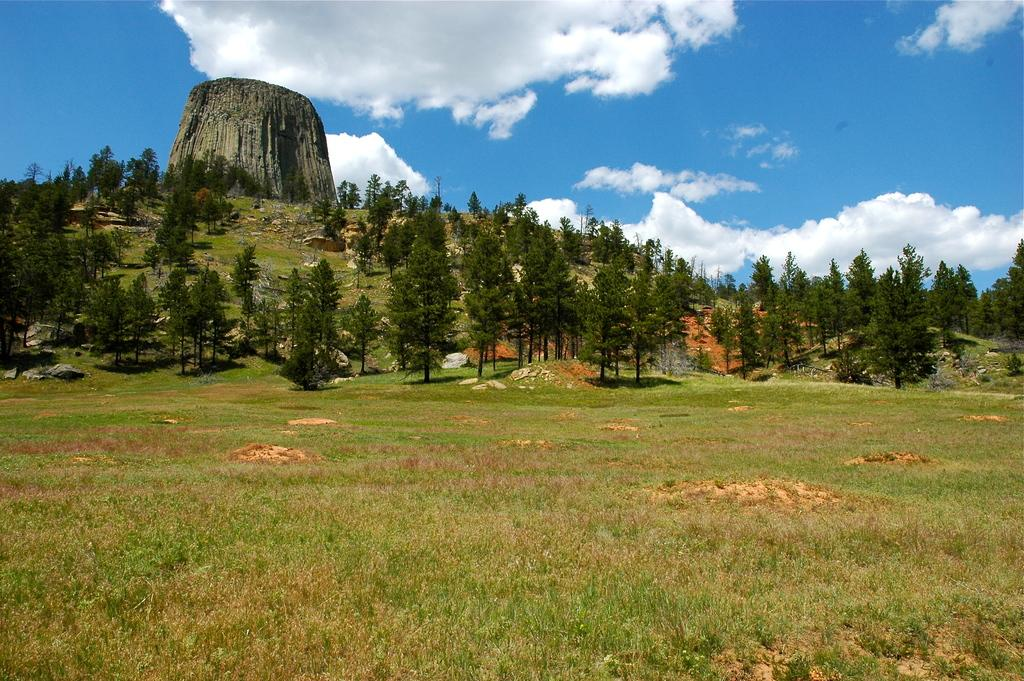What type of ground surface is visible in the image? There is grass on the ground in the image. What can be seen in the distance in the image? There are trees in the background of the image. Can you describe the tree in the background more specifically? There is a tree trunk in the background of the image. How would you describe the sky in the image? The sky is blue and cloudy in the image. Is the person in the image sleeping on the grass? There is no person present in the image, so it is not possible to determine if someone is sleeping on the grass. 